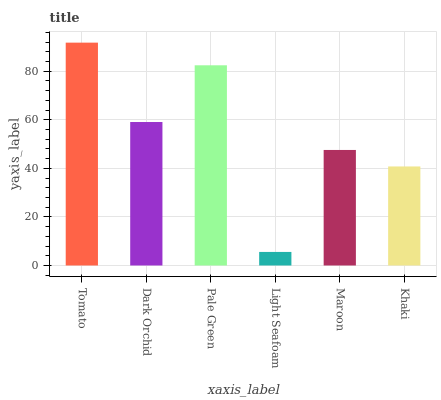Is Dark Orchid the minimum?
Answer yes or no. No. Is Dark Orchid the maximum?
Answer yes or no. No. Is Tomato greater than Dark Orchid?
Answer yes or no. Yes. Is Dark Orchid less than Tomato?
Answer yes or no. Yes. Is Dark Orchid greater than Tomato?
Answer yes or no. No. Is Tomato less than Dark Orchid?
Answer yes or no. No. Is Dark Orchid the high median?
Answer yes or no. Yes. Is Maroon the low median?
Answer yes or no. Yes. Is Maroon the high median?
Answer yes or no. No. Is Light Seafoam the low median?
Answer yes or no. No. 